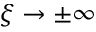Convert formula to latex. <formula><loc_0><loc_0><loc_500><loc_500>\xi \to \pm \infty</formula> 